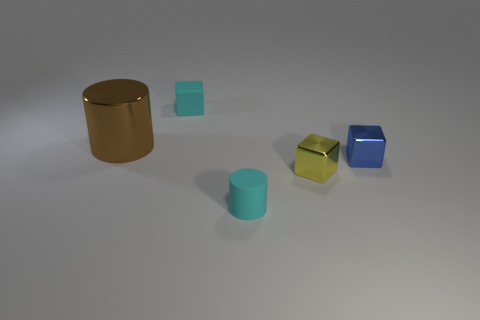There is a brown cylinder that is the same material as the blue object; what size is it?
Your answer should be compact. Large. What is the color of the metallic object that is on the left side of the small object that is behind the large brown cylinder?
Your answer should be compact. Brown. There is a tiny blue metal thing; is it the same shape as the tiny rubber object behind the tiny blue thing?
Provide a succinct answer. Yes. What number of other metallic cylinders are the same size as the brown cylinder?
Your answer should be very brief. 0. There is a tiny yellow thing that is the same shape as the small blue thing; what is its material?
Your response must be concise. Metal. There is a matte object that is in front of the blue metallic object; is it the same color as the small matte thing that is behind the large cylinder?
Give a very brief answer. Yes. There is a small cyan thing that is behind the large brown object; what shape is it?
Keep it short and to the point. Cube. The tiny cylinder has what color?
Your response must be concise. Cyan. The small yellow thing that is the same material as the brown object is what shape?
Give a very brief answer. Cube. Do the cyan thing right of the matte cube and the big brown thing have the same size?
Offer a very short reply. No. 